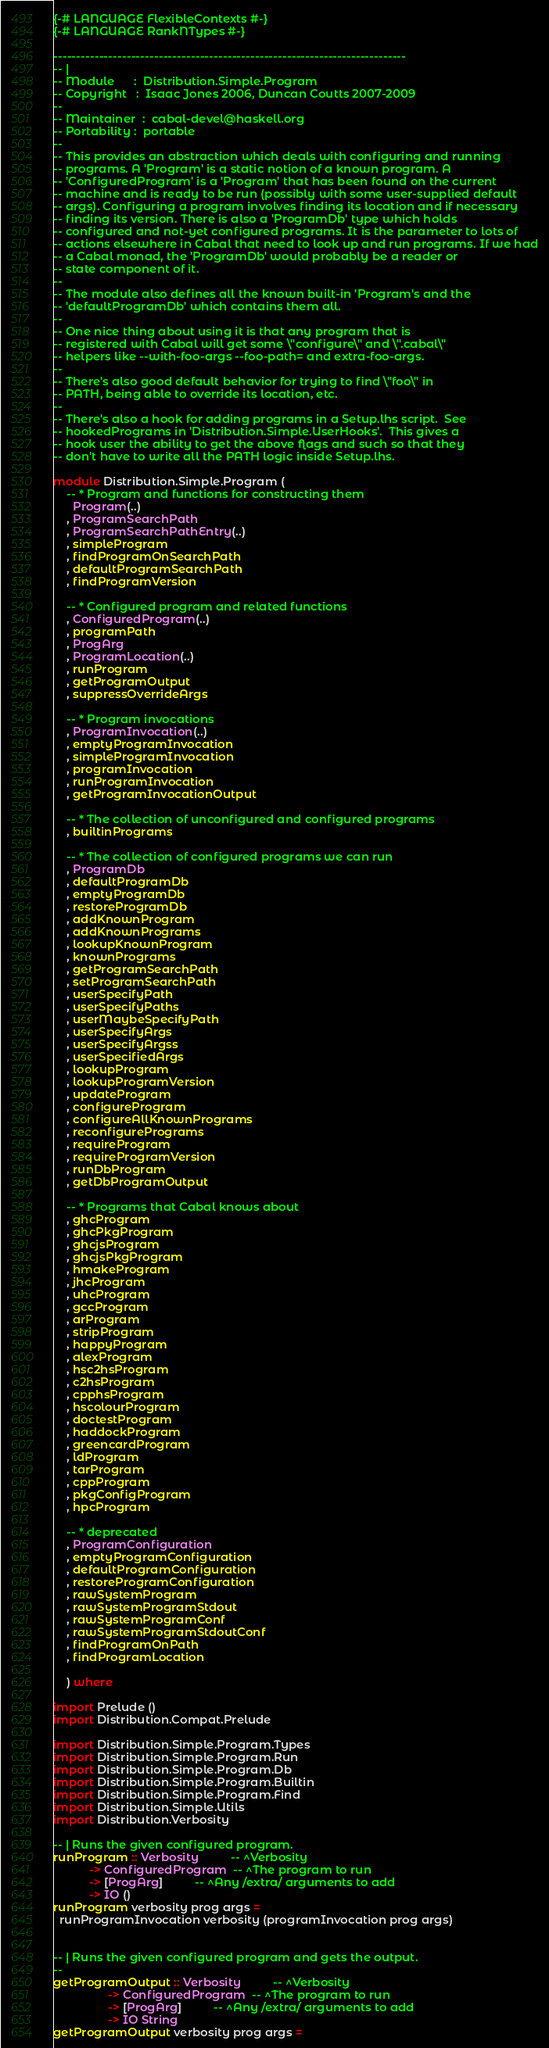<code> <loc_0><loc_0><loc_500><loc_500><_Haskell_>{-# LANGUAGE FlexibleContexts #-}
{-# LANGUAGE RankNTypes #-}

-----------------------------------------------------------------------------
-- |
-- Module      :  Distribution.Simple.Program
-- Copyright   :  Isaac Jones 2006, Duncan Coutts 2007-2009
--
-- Maintainer  :  cabal-devel@haskell.org
-- Portability :  portable
--
-- This provides an abstraction which deals with configuring and running
-- programs. A 'Program' is a static notion of a known program. A
-- 'ConfiguredProgram' is a 'Program' that has been found on the current
-- machine and is ready to be run (possibly with some user-supplied default
-- args). Configuring a program involves finding its location and if necessary
-- finding its version. There is also a 'ProgramDb' type which holds
-- configured and not-yet configured programs. It is the parameter to lots of
-- actions elsewhere in Cabal that need to look up and run programs. If we had
-- a Cabal monad, the 'ProgramDb' would probably be a reader or
-- state component of it.
--
-- The module also defines all the known built-in 'Program's and the
-- 'defaultProgramDb' which contains them all.
--
-- One nice thing about using it is that any program that is
-- registered with Cabal will get some \"configure\" and \".cabal\"
-- helpers like --with-foo-args --foo-path= and extra-foo-args.
--
-- There's also good default behavior for trying to find \"foo\" in
-- PATH, being able to override its location, etc.
--
-- There's also a hook for adding programs in a Setup.lhs script.  See
-- hookedPrograms in 'Distribution.Simple.UserHooks'.  This gives a
-- hook user the ability to get the above flags and such so that they
-- don't have to write all the PATH logic inside Setup.lhs.

module Distribution.Simple.Program (
    -- * Program and functions for constructing them
      Program(..)
    , ProgramSearchPath
    , ProgramSearchPathEntry(..)
    , simpleProgram
    , findProgramOnSearchPath
    , defaultProgramSearchPath
    , findProgramVersion

    -- * Configured program and related functions
    , ConfiguredProgram(..)
    , programPath
    , ProgArg
    , ProgramLocation(..)
    , runProgram
    , getProgramOutput
    , suppressOverrideArgs

    -- * Program invocations
    , ProgramInvocation(..)
    , emptyProgramInvocation
    , simpleProgramInvocation
    , programInvocation
    , runProgramInvocation
    , getProgramInvocationOutput

    -- * The collection of unconfigured and configured programs
    , builtinPrograms

    -- * The collection of configured programs we can run
    , ProgramDb
    , defaultProgramDb
    , emptyProgramDb
    , restoreProgramDb
    , addKnownProgram
    , addKnownPrograms
    , lookupKnownProgram
    , knownPrograms
    , getProgramSearchPath
    , setProgramSearchPath
    , userSpecifyPath
    , userSpecifyPaths
    , userMaybeSpecifyPath
    , userSpecifyArgs
    , userSpecifyArgss
    , userSpecifiedArgs
    , lookupProgram
    , lookupProgramVersion
    , updateProgram
    , configureProgram
    , configureAllKnownPrograms
    , reconfigurePrograms
    , requireProgram
    , requireProgramVersion
    , runDbProgram
    , getDbProgramOutput

    -- * Programs that Cabal knows about
    , ghcProgram
    , ghcPkgProgram
    , ghcjsProgram
    , ghcjsPkgProgram
    , hmakeProgram
    , jhcProgram
    , uhcProgram
    , gccProgram
    , arProgram
    , stripProgram
    , happyProgram
    , alexProgram
    , hsc2hsProgram
    , c2hsProgram
    , cpphsProgram
    , hscolourProgram
    , doctestProgram
    , haddockProgram
    , greencardProgram
    , ldProgram
    , tarProgram
    , cppProgram
    , pkgConfigProgram
    , hpcProgram

    -- * deprecated
    , ProgramConfiguration
    , emptyProgramConfiguration
    , defaultProgramConfiguration
    , restoreProgramConfiguration
    , rawSystemProgram
    , rawSystemProgramStdout
    , rawSystemProgramConf
    , rawSystemProgramStdoutConf
    , findProgramOnPath
    , findProgramLocation

    ) where

import Prelude ()
import Distribution.Compat.Prelude

import Distribution.Simple.Program.Types
import Distribution.Simple.Program.Run
import Distribution.Simple.Program.Db
import Distribution.Simple.Program.Builtin
import Distribution.Simple.Program.Find
import Distribution.Simple.Utils
import Distribution.Verbosity

-- | Runs the given configured program.
runProgram :: Verbosity          -- ^Verbosity
           -> ConfiguredProgram  -- ^The program to run
           -> [ProgArg]          -- ^Any /extra/ arguments to add
           -> IO ()
runProgram verbosity prog args =
  runProgramInvocation verbosity (programInvocation prog args)


-- | Runs the given configured program and gets the output.
--
getProgramOutput :: Verbosity          -- ^Verbosity
                 -> ConfiguredProgram  -- ^The program to run
                 -> [ProgArg]          -- ^Any /extra/ arguments to add
                 -> IO String
getProgramOutput verbosity prog args =</code> 